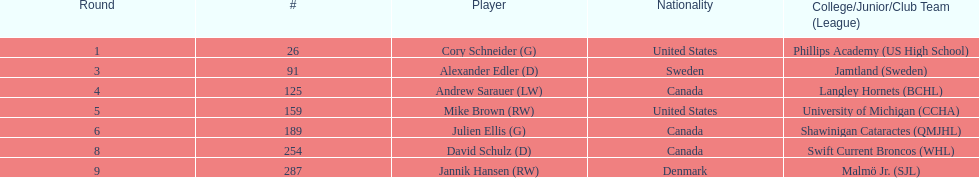Who is the exclusive player with danish nationality? Jannik Hansen (RW). 